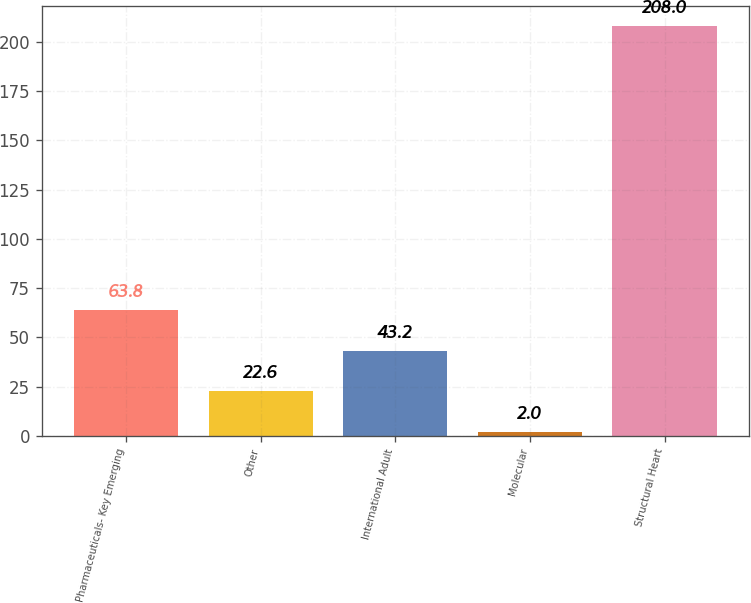Convert chart. <chart><loc_0><loc_0><loc_500><loc_500><bar_chart><fcel>Pharmaceuticals- Key Emerging<fcel>Other<fcel>International Adult<fcel>Molecular<fcel>Structural Heart<nl><fcel>63.8<fcel>22.6<fcel>43.2<fcel>2<fcel>208<nl></chart> 